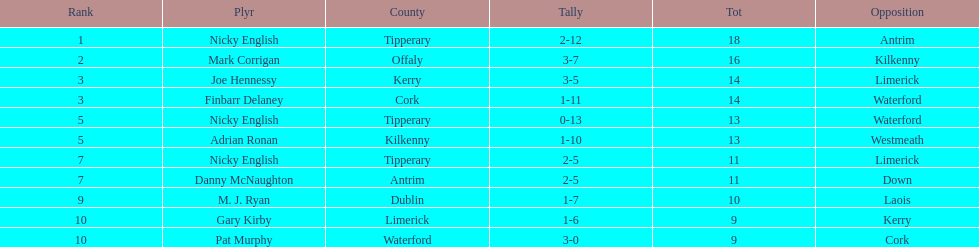If you added all the total's up, what would the number be? 138. 